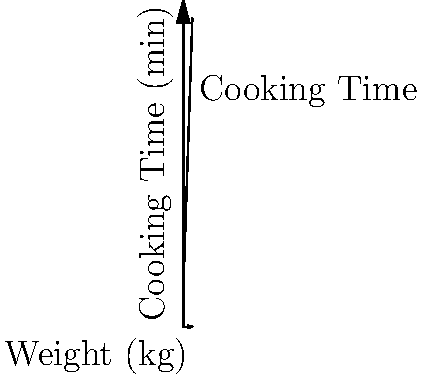G'day! You're preparing a roast for your family's Sunday dinner while catching up on the latest episode of MasterChef Australia. The cooking time for the roast depends on its weight, following the formula: Cooking Time (in minutes) = 20 + 30 * Weight (in kg). If your roast weighs 3.5 kg, how long should you cook it for? Let's work this out step-by-step, just like they do in those cooking challenges on MasterChef:

1. We're given the formula: 
   Cooking Time = 20 + 30 * Weight

2. We know our roast weighs 3.5 kg, so let's plug that into the formula:
   Cooking Time = 20 + 30 * 3.5

3. Let's solve the multiplication first:
   30 * 3.5 = 105

4. Now we can add:
   Cooking Time = 20 + 105 = 125

So, the cooking time for our 3.5 kg roast is 125 minutes.

5. To convert this to hours and minutes:
   125 minutes = 2 hours and 5 minutes

This is perfect timing to watch a full episode of your favourite reality TV show while the roast is in the oven!
Answer: 2 hours and 5 minutes 